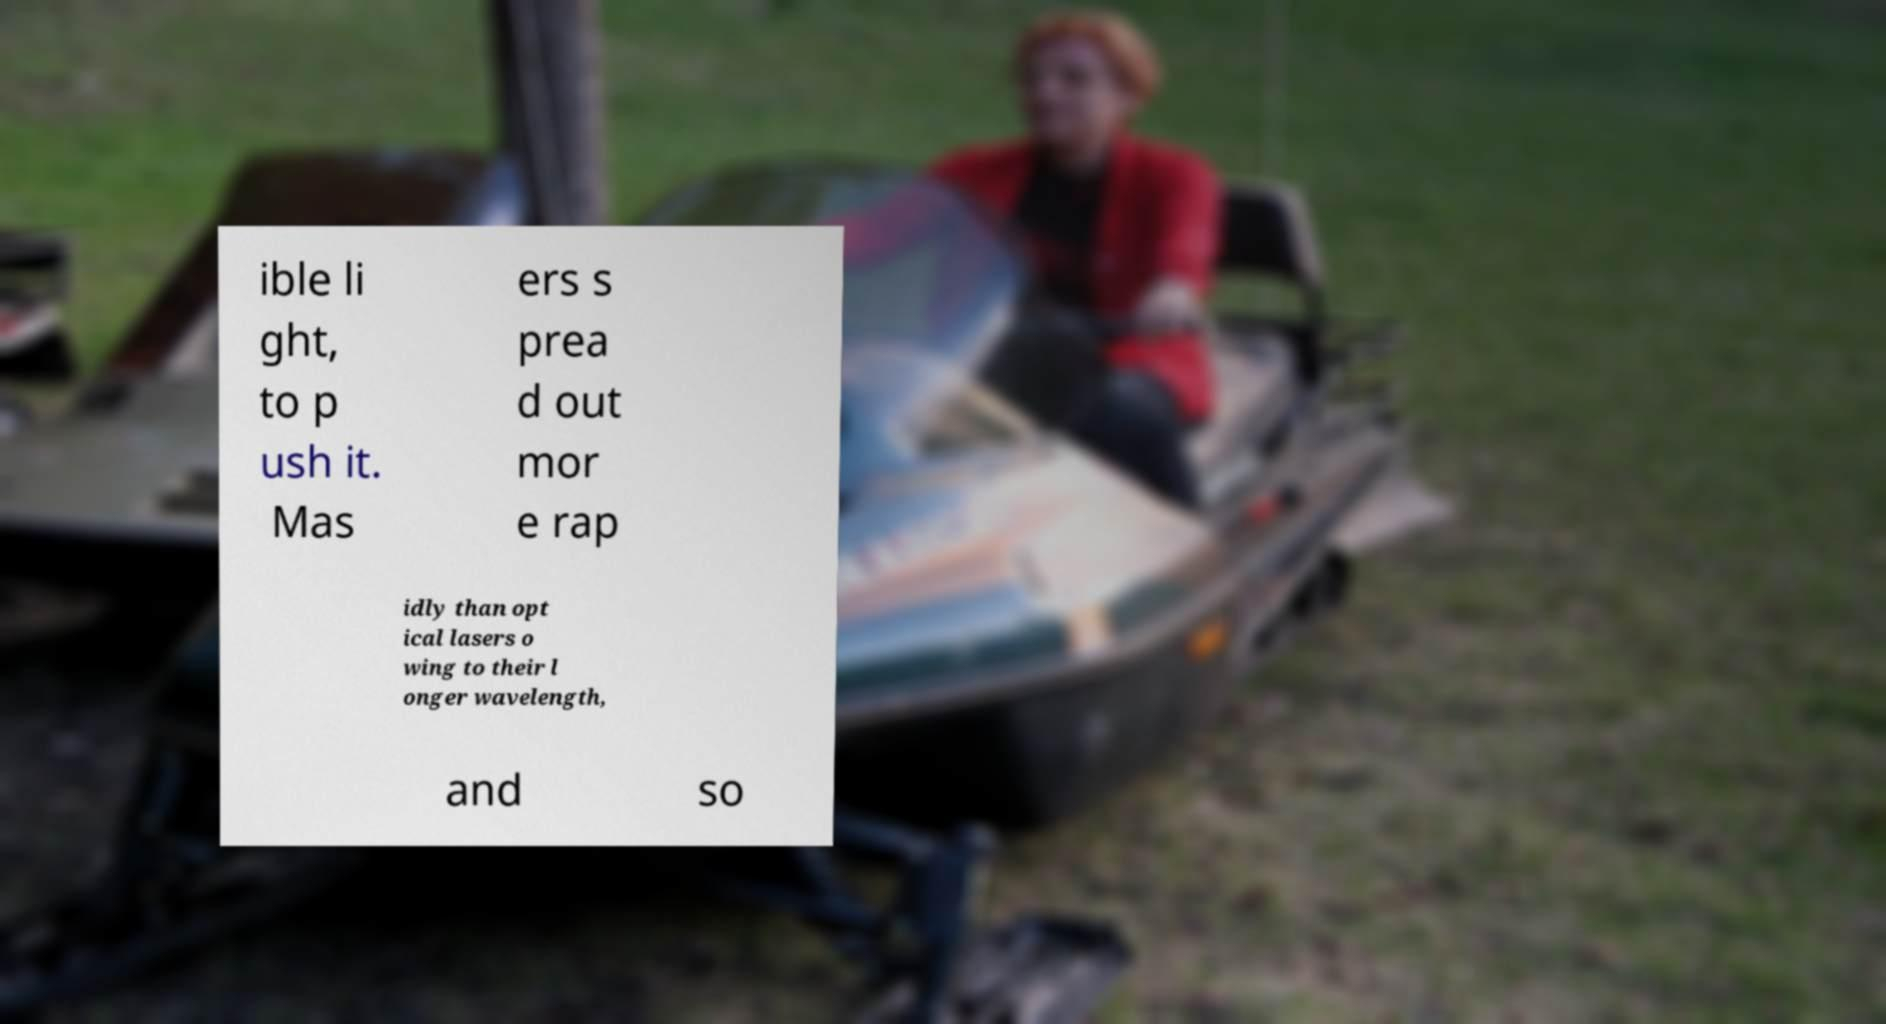I need the written content from this picture converted into text. Can you do that? ible li ght, to p ush it. Mas ers s prea d out mor e rap idly than opt ical lasers o wing to their l onger wavelength, and so 